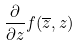Convert formula to latex. <formula><loc_0><loc_0><loc_500><loc_500>\frac { \partial } { \partial z } f ( \overline { z } , z )</formula> 